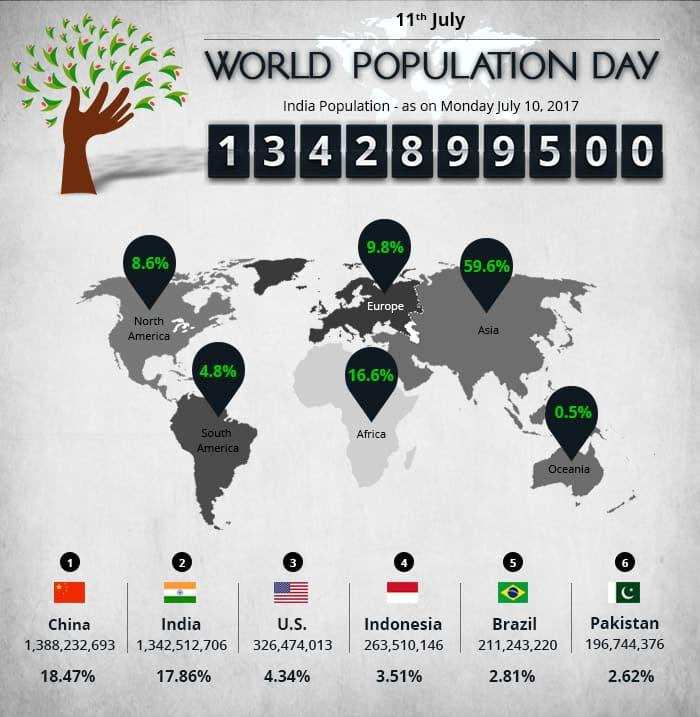Specify some key components in this picture. Asia is the most populous continent in the world. Oceania is the least populous continent in the world. It is estimated that if the populations of Asia and Europe were combined, the total percentage would be approximately 69.4%. The total population of India and Pakistan taken together is approximately 20.48%. North America is the most populous continent among North America and South America. 